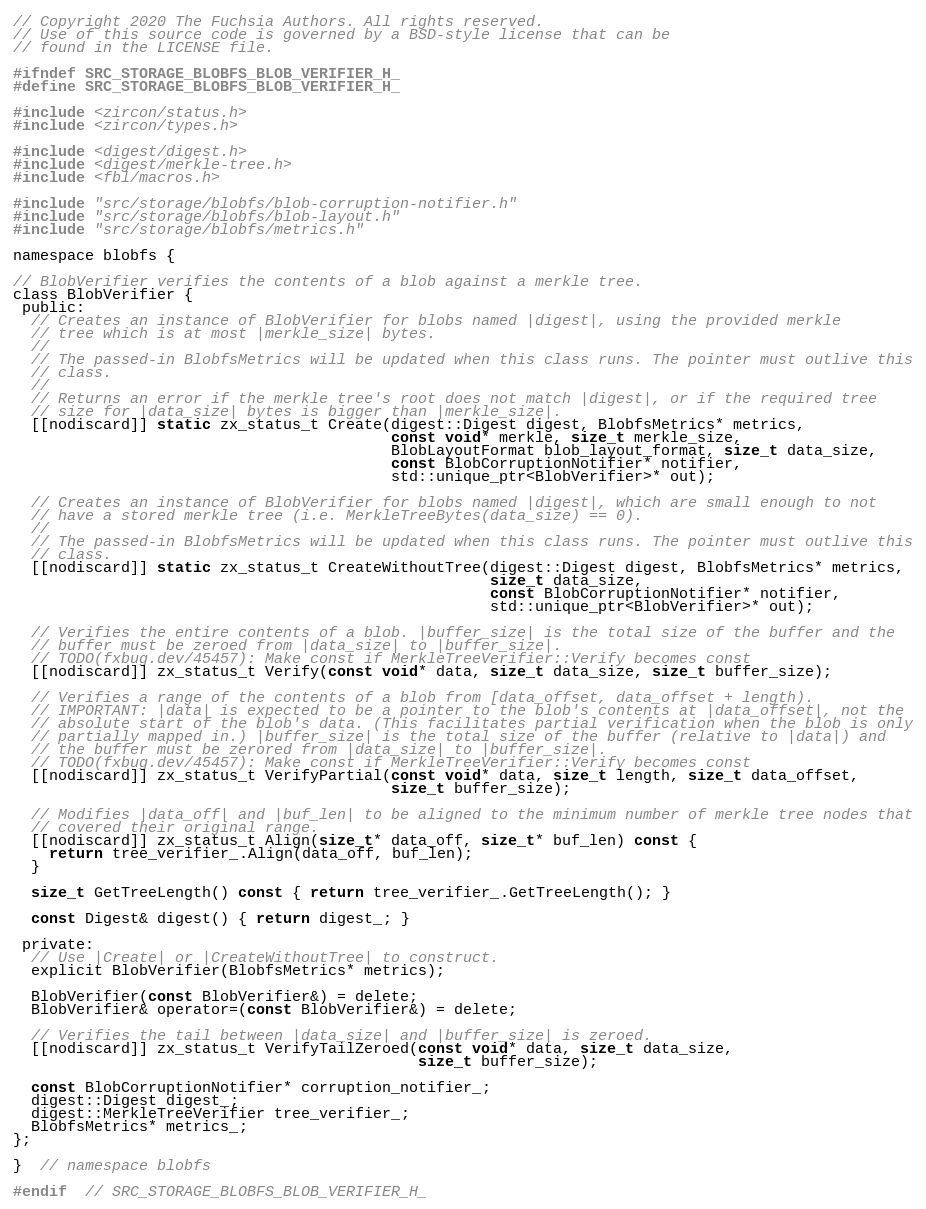Convert code to text. <code><loc_0><loc_0><loc_500><loc_500><_C_>// Copyright 2020 The Fuchsia Authors. All rights reserved.
// Use of this source code is governed by a BSD-style license that can be
// found in the LICENSE file.

#ifndef SRC_STORAGE_BLOBFS_BLOB_VERIFIER_H_
#define SRC_STORAGE_BLOBFS_BLOB_VERIFIER_H_

#include <zircon/status.h>
#include <zircon/types.h>

#include <digest/digest.h>
#include <digest/merkle-tree.h>
#include <fbl/macros.h>

#include "src/storage/blobfs/blob-corruption-notifier.h"
#include "src/storage/blobfs/blob-layout.h"
#include "src/storage/blobfs/metrics.h"

namespace blobfs {

// BlobVerifier verifies the contents of a blob against a merkle tree.
class BlobVerifier {
 public:
  // Creates an instance of BlobVerifier for blobs named |digest|, using the provided merkle
  // tree which is at most |merkle_size| bytes.
  //
  // The passed-in BlobfsMetrics will be updated when this class runs. The pointer must outlive this
  // class.
  //
  // Returns an error if the merkle tree's root does not match |digest|, or if the required tree
  // size for |data_size| bytes is bigger than |merkle_size|.
  [[nodiscard]] static zx_status_t Create(digest::Digest digest, BlobfsMetrics* metrics,
                                          const void* merkle, size_t merkle_size,
                                          BlobLayoutFormat blob_layout_format, size_t data_size,
                                          const BlobCorruptionNotifier* notifier,
                                          std::unique_ptr<BlobVerifier>* out);

  // Creates an instance of BlobVerifier for blobs named |digest|, which are small enough to not
  // have a stored merkle tree (i.e. MerkleTreeBytes(data_size) == 0).
  //
  // The passed-in BlobfsMetrics will be updated when this class runs. The pointer must outlive this
  // class.
  [[nodiscard]] static zx_status_t CreateWithoutTree(digest::Digest digest, BlobfsMetrics* metrics,
                                                     size_t data_size,
                                                     const BlobCorruptionNotifier* notifier,
                                                     std::unique_ptr<BlobVerifier>* out);

  // Verifies the entire contents of a blob. |buffer_size| is the total size of the buffer and the
  // buffer must be zeroed from |data_size| to |buffer_size|.
  // TODO(fxbug.dev/45457): Make const if MerkleTreeVerifier::Verify becomes const
  [[nodiscard]] zx_status_t Verify(const void* data, size_t data_size, size_t buffer_size);

  // Verifies a range of the contents of a blob from [data_offset, data_offset + length).
  // IMPORTANT: |data| is expected to be a pointer to the blob's contents at |data_offset|, not the
  // absolute start of the blob's data. (This facilitates partial verification when the blob is only
  // partially mapped in.) |buffer_size| is the total size of the buffer (relative to |data|) and
  // the buffer must be zerored from |data_size| to |buffer_size|.
  // TODO(fxbug.dev/45457): Make const if MerkleTreeVerifier::Verify becomes const
  [[nodiscard]] zx_status_t VerifyPartial(const void* data, size_t length, size_t data_offset,
                                          size_t buffer_size);

  // Modifies |data_off| and |buf_len| to be aligned to the minimum number of merkle tree nodes that
  // covered their original range.
  [[nodiscard]] zx_status_t Align(size_t* data_off, size_t* buf_len) const {
    return tree_verifier_.Align(data_off, buf_len);
  }

  size_t GetTreeLength() const { return tree_verifier_.GetTreeLength(); }

  const Digest& digest() { return digest_; }

 private:
  // Use |Create| or |CreateWithoutTree| to construct.
  explicit BlobVerifier(BlobfsMetrics* metrics);

  BlobVerifier(const BlobVerifier&) = delete;
  BlobVerifier& operator=(const BlobVerifier&) = delete;

  // Verifies the tail between |data_size| and |buffer_size| is zeroed.
  [[nodiscard]] zx_status_t VerifyTailZeroed(const void* data, size_t data_size,
                                             size_t buffer_size);

  const BlobCorruptionNotifier* corruption_notifier_;
  digest::Digest digest_;
  digest::MerkleTreeVerifier tree_verifier_;
  BlobfsMetrics* metrics_;
};

}  // namespace blobfs

#endif  // SRC_STORAGE_BLOBFS_BLOB_VERIFIER_H_
</code> 